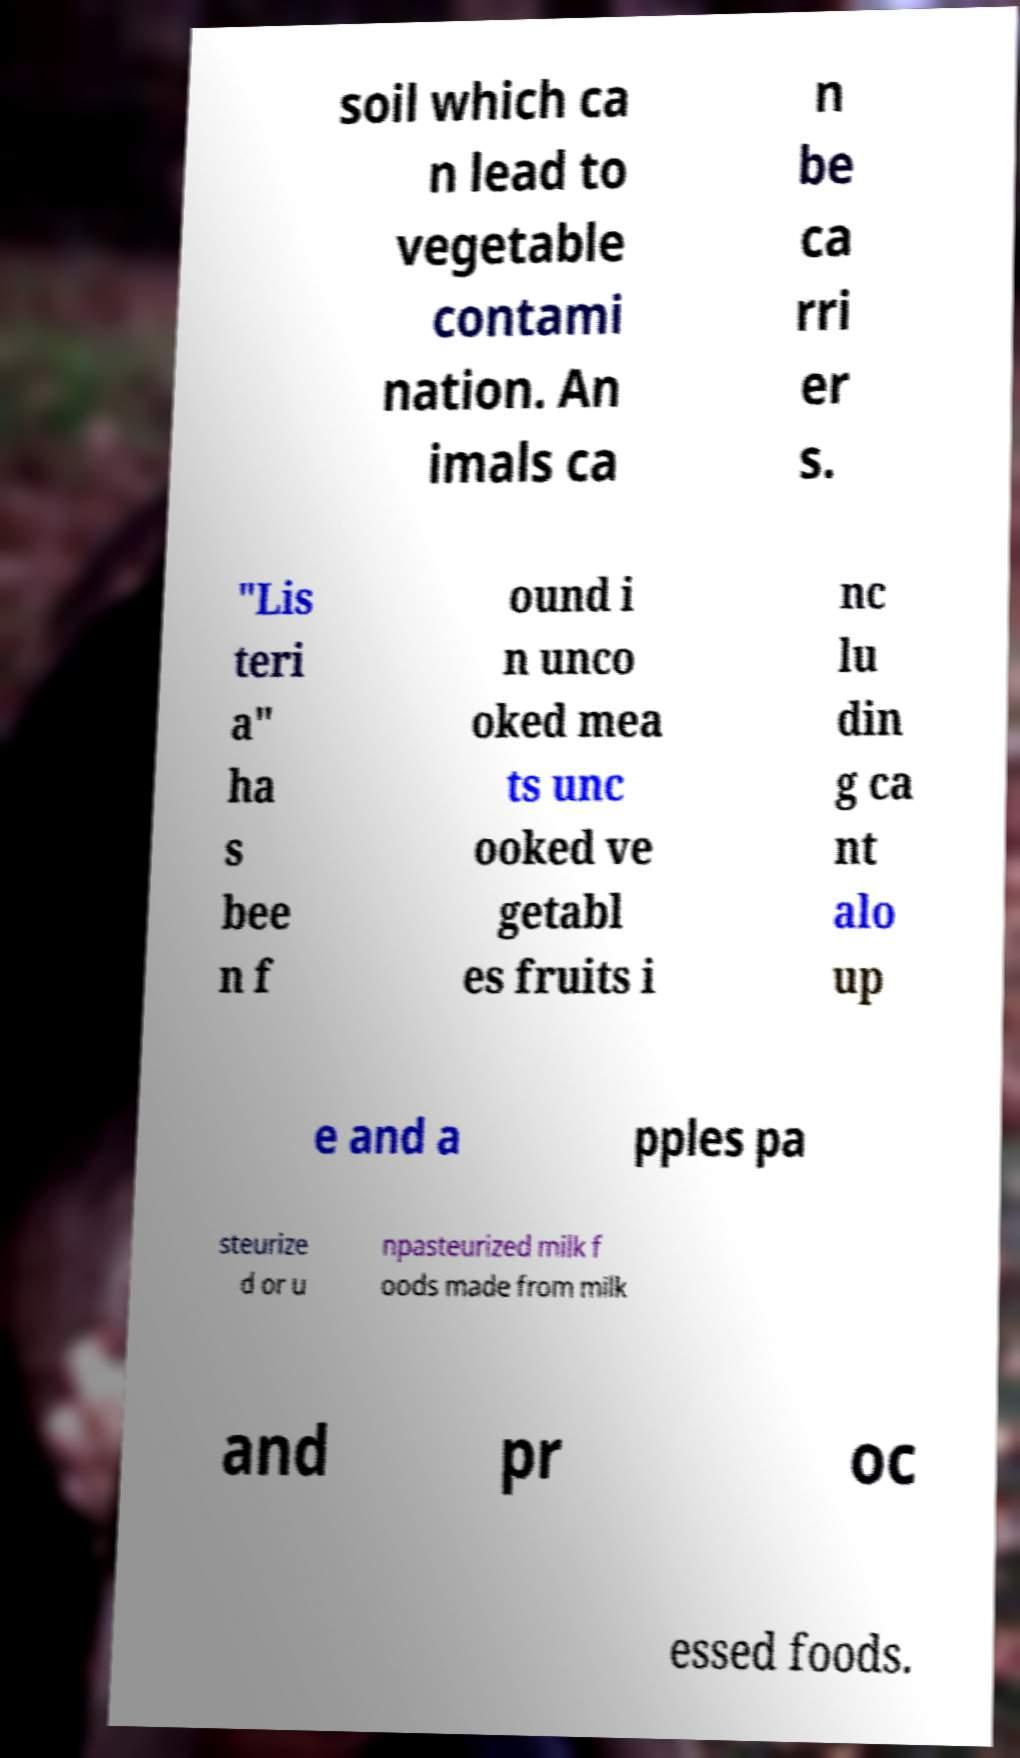What messages or text are displayed in this image? I need them in a readable, typed format. soil which ca n lead to vegetable contami nation. An imals ca n be ca rri er s. "Lis teri a" ha s bee n f ound i n unco oked mea ts unc ooked ve getabl es fruits i nc lu din g ca nt alo up e and a pples pa steurize d or u npasteurized milk f oods made from milk and pr oc essed foods. 